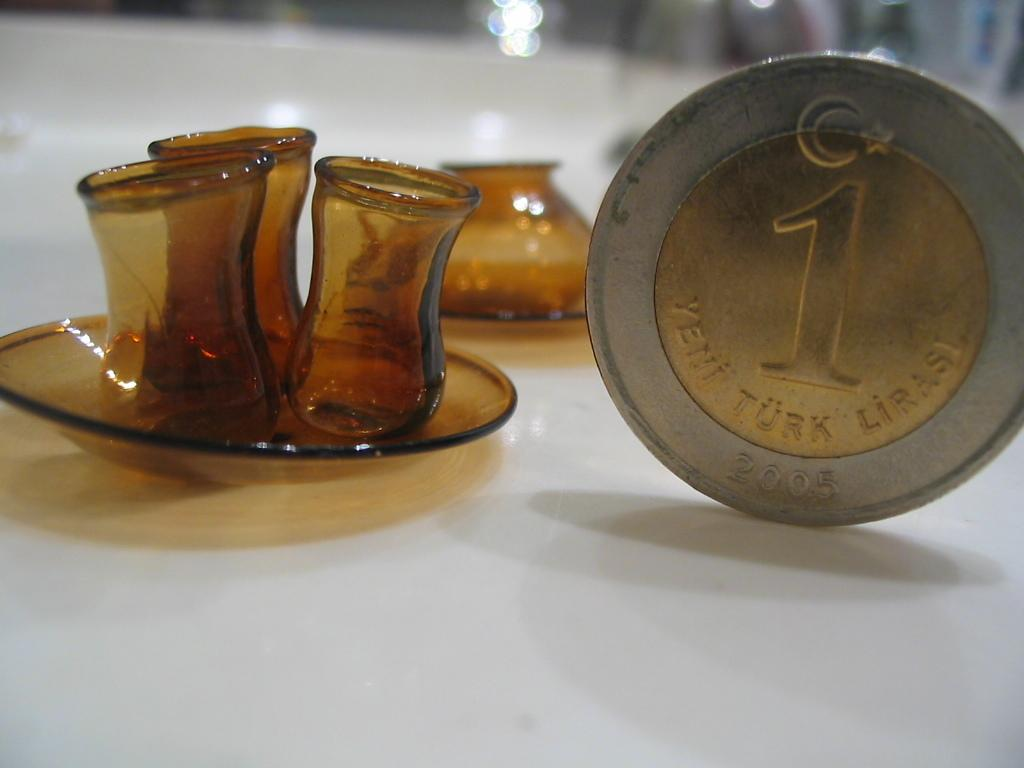What object can be seen on the ground in the image? There is a coin on the ground in the image. What type of objects are visible in the image that are typically used for drinking? There are glasses in the image. What other object can be seen on the ground in the image? There is a saucer on the ground in the image. How would you describe the background of the image? The background of the image is blurred. What type of brass instrument can be seen in the image? There is no brass instrument present in the image. What type of shock might the coin on the ground cause in the image? The coin on the ground does not cause any shock in the image. 